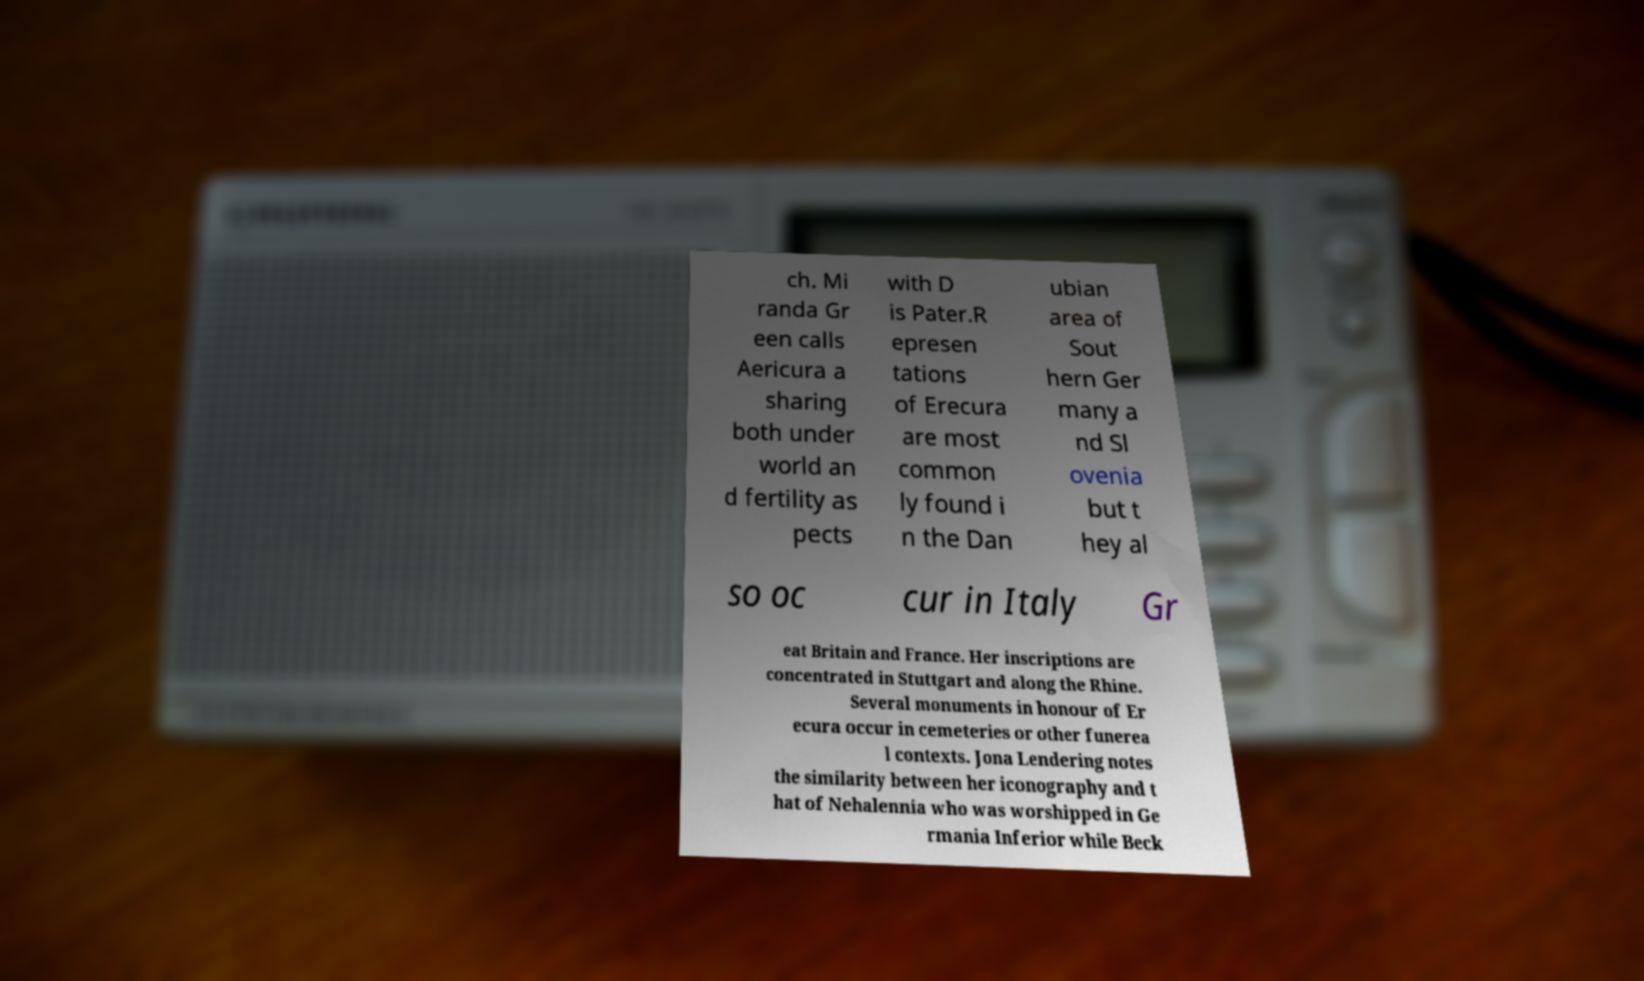Could you assist in decoding the text presented in this image and type it out clearly? ch. Mi randa Gr een calls Aericura a sharing both under world an d fertility as pects with D is Pater.R epresen tations of Erecura are most common ly found i n the Dan ubian area of Sout hern Ger many a nd Sl ovenia but t hey al so oc cur in Italy Gr eat Britain and France. Her inscriptions are concentrated in Stuttgart and along the Rhine. Several monuments in honour of Er ecura occur in cemeteries or other funerea l contexts. Jona Lendering notes the similarity between her iconography and t hat of Nehalennia who was worshipped in Ge rmania Inferior while Beck 